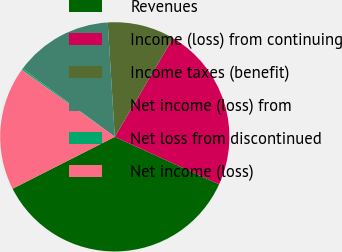Convert chart to OTSL. <chart><loc_0><loc_0><loc_500><loc_500><pie_chart><fcel>Revenues<fcel>Income (loss) from continuing<fcel>Income taxes (benefit)<fcel>Net income (loss) from<fcel>Net loss from discontinued<fcel>Net income (loss)<nl><fcel>35.72%<fcel>23.32%<fcel>9.46%<fcel>13.86%<fcel>0.23%<fcel>17.41%<nl></chart> 